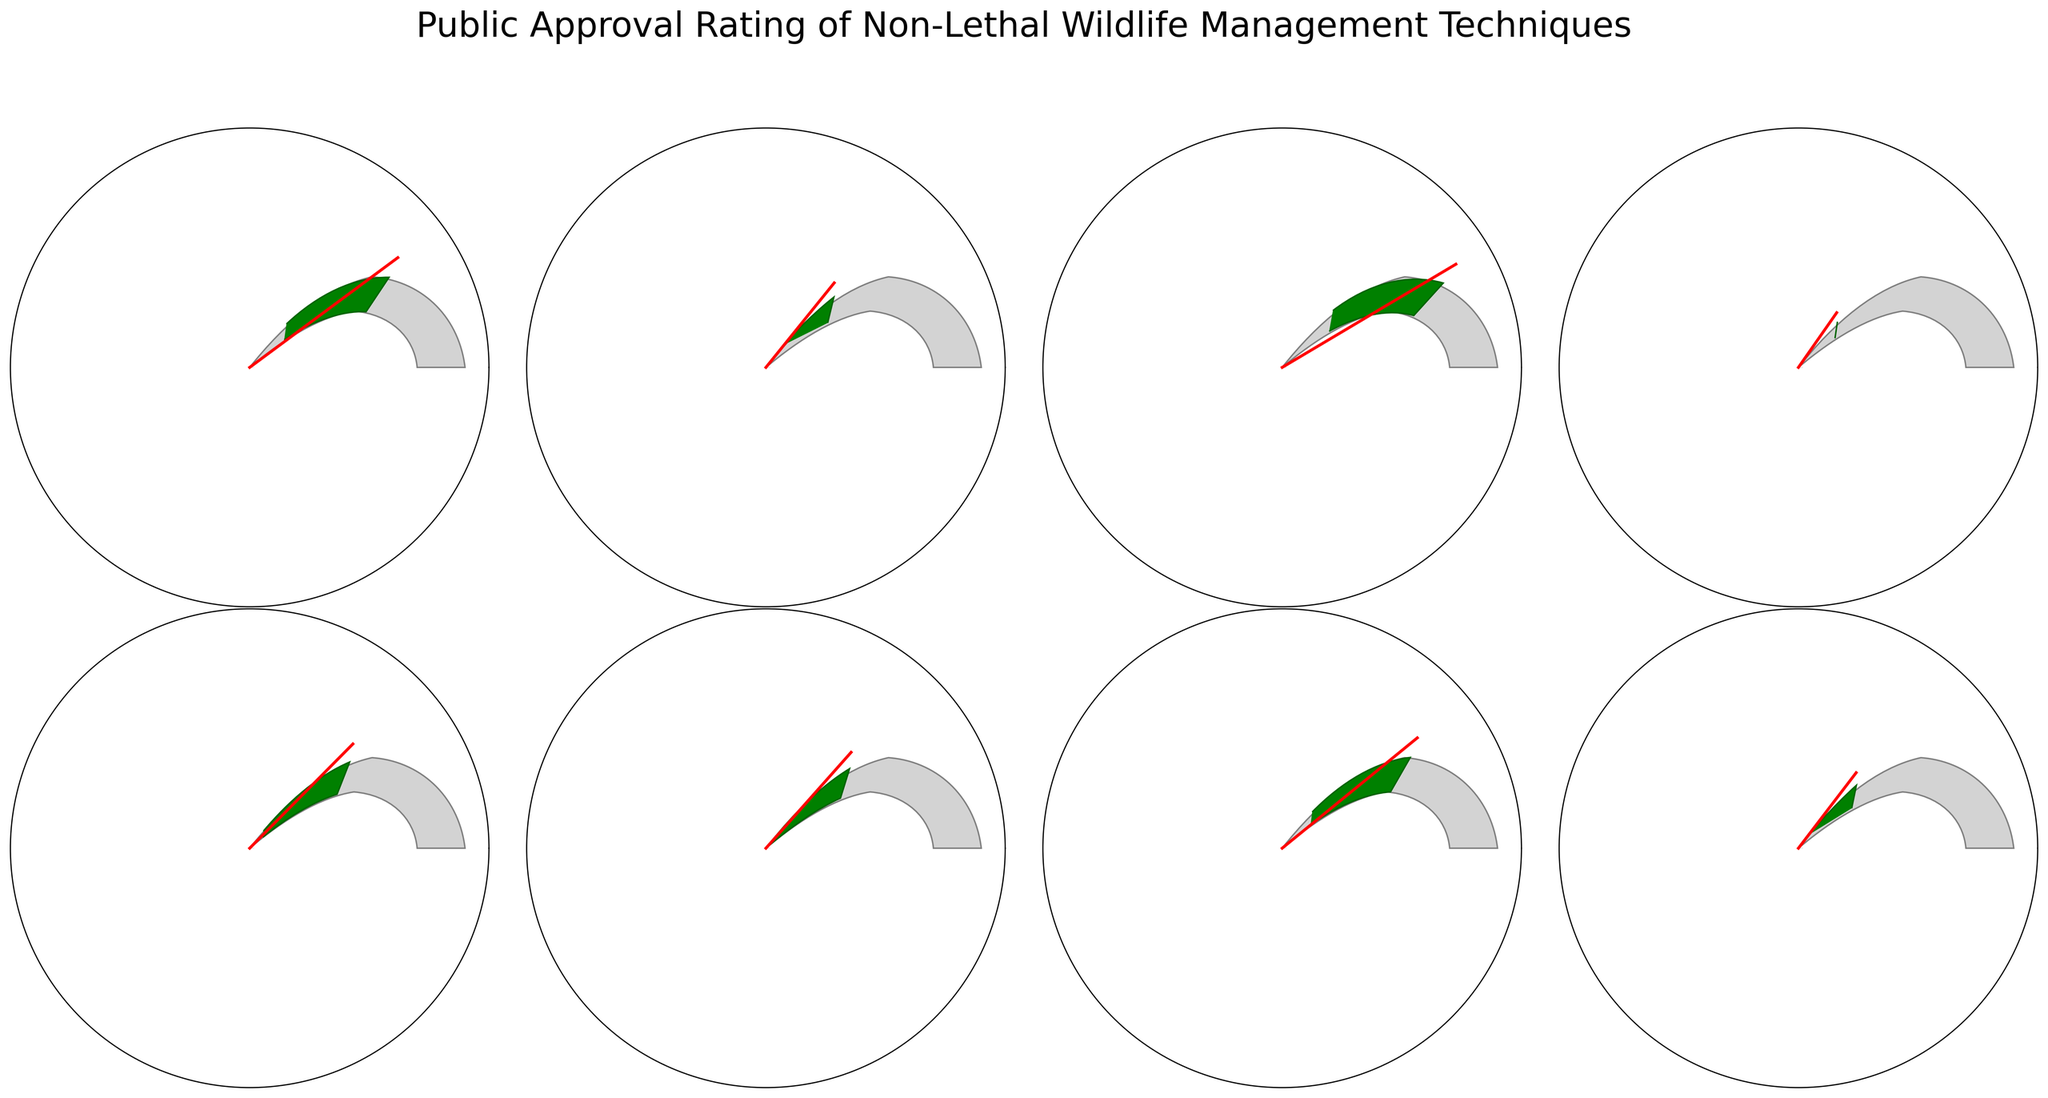What's the title of the figure? The title of the figure is displayed at the top, and it reads "Public Approval Rating of Non-Lethal Wildlife Management Techniques."
Answer: Public Approval Rating of Non-Lethal Wildlife Management Techniques How many techniques are evaluated in the figure? By counting the individual gauge charts, we can see that there are 8 techniques evaluated in the figure.
Answer: 8 Which technique has the highest approval rating? By looking at the ratings in the center of each gauge chart, the highest rating is 82% for "Habitat Modification."
Answer: Habitat Modification What's the average approval rating of all the techniques? The approval ratings are: 78, 65, 82, 59, 71, 68, 76, and 63. Summing these gives 562. Dividing by the number of techniques (8) gives an average of 562/8 = 70.25.
Answer: 70.25 What's the range of the approval ratings? The highest rating is 82% (Habitat Modification) and the lowest is 59% (Scare Devices). The range is 82 - 59 = 23.
Answer: 23 Which technique's approval rating is closest to the overall average? The overall average approval rating is 70.25%. Looking at the individual ratings, "Translocation" has an approval rating of 71%, which is closest to the average.
Answer: Translocation How many techniques have an approval rating greater than 70%? Counting the ratings greater than 70%: 78 (Fencing), 82 (Habitat Modification), 71 (Translocation), and 76 (Guard Animals). This gives a total of 4 techniques.
Answer: 4 Which techniques have an approval rating less than 65%? The techniques with ratings less than 65% are "Repellents" (65%), "Scare Devices" (59%), and "Diversionary Feeding" (63%).
Answer: Repellents, Scare Devices, Diversionary Feeding Which techniques are rated between 60% and 70%? From the ratings, "Repellents" (65%), "Scare Devices" (59%), "Diversionary Feeding" (63%), and "Contraception" (68%) fall in (or very close to) the range of 60% to 70%, excluding "Scare Devices" exactly at 59%.*
Answer: Repellents, Diversionary Feeding, Contraception (*considering edge case 59% exclusion) If you combine the approval ratings of the top 2 rated techniques, what's the total? The top 2 rated techniques are "Habitat Modification" (82%) and "Fencing" (78%). Summing these ratings gives 82 + 78 = 160.
Answer: 160 